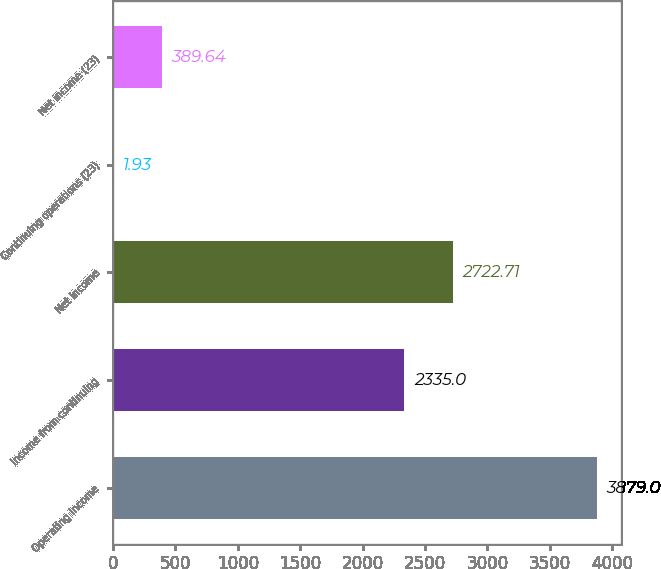Convert chart. <chart><loc_0><loc_0><loc_500><loc_500><bar_chart><fcel>Operating income<fcel>Income from continuing<fcel>Net income<fcel>Continuing operations (23)<fcel>Net income (23)<nl><fcel>3879<fcel>2335<fcel>2722.71<fcel>1.93<fcel>389.64<nl></chart> 